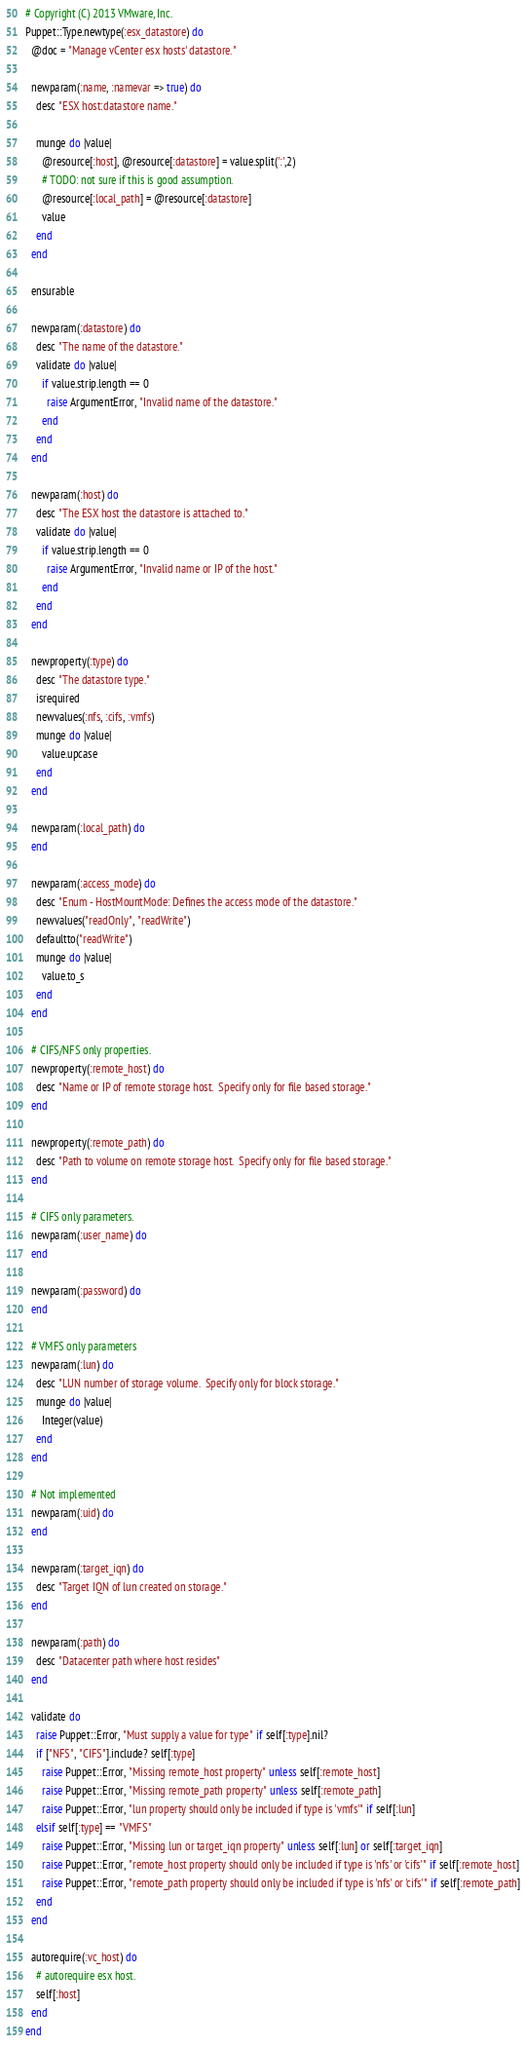<code> <loc_0><loc_0><loc_500><loc_500><_Ruby_># Copyright (C) 2013 VMware, Inc.
Puppet::Type.newtype(:esx_datastore) do
  @doc = "Manage vCenter esx hosts' datastore."

  newparam(:name, :namevar => true) do
    desc "ESX host:datastore name."

    munge do |value|
      @resource[:host], @resource[:datastore] = value.split(':',2)
      # TODO: not sure if this is good assumption.
      @resource[:local_path] = @resource[:datastore]
      value
    end
  end

  ensurable

  newparam(:datastore) do
    desc "The name of the datastore."
    validate do |value|
      if value.strip.length == 0
        raise ArgumentError, "Invalid name of the datastore."
      end
    end
  end

  newparam(:host) do
    desc "The ESX host the datastore is attached to."
    validate do |value|
      if value.strip.length == 0
        raise ArgumentError, "Invalid name or IP of the host."
      end
    end
  end

  newproperty(:type) do
    desc "The datastore type."
    isrequired
    newvalues(:nfs, :cifs, :vmfs)
    munge do |value|
      value.upcase
    end
  end

  newparam(:local_path) do
  end

  newparam(:access_mode) do
    desc "Enum - HostMountMode: Defines the access mode of the datastore."
    newvalues("readOnly", "readWrite")
    defaultto("readWrite")
    munge do |value|
      value.to_s
    end
  end

  # CIFS/NFS only properties.
  newproperty(:remote_host) do
    desc "Name or IP of remote storage host.  Specify only for file based storage."
  end

  newproperty(:remote_path) do
    desc "Path to volume on remote storage host.  Specify only for file based storage."
  end

  # CIFS only parameters.
  newparam(:user_name) do
  end

  newparam(:password) do
  end

  # VMFS only parameters
  newparam(:lun) do
    desc "LUN number of storage volume.  Specify only for block storage."
    munge do |value|
      Integer(value)
    end
  end

  # Not implemented
  newparam(:uid) do
  end

  newparam(:target_iqn) do
    desc "Target IQN of lun created on storage."
  end

  newparam(:path) do
    desc "Datacenter path where host resides"
  end

  validate do
    raise Puppet::Error, "Must supply a value for type" if self[:type].nil?
    if ["NFS", "CIFS"].include? self[:type]
      raise Puppet::Error, "Missing remote_host property" unless self[:remote_host]
      raise Puppet::Error, "Missing remote_path property" unless self[:remote_path]
      raise Puppet::Error, "lun property should only be included if type is 'vmfs'" if self[:lun]
    elsif self[:type] == "VMFS"
      raise Puppet::Error, "Missing lun or target_iqn property" unless self[:lun] or self[:target_iqn]
      raise Puppet::Error, "remote_host property should only be included if type is 'nfs' or 'cifs'" if self[:remote_host]
      raise Puppet::Error, "remote_path property should only be included if type is 'nfs' or 'cifs'" if self[:remote_path]
    end
  end

  autorequire(:vc_host) do
    # autorequire esx host.
    self[:host]
  end
end
</code> 